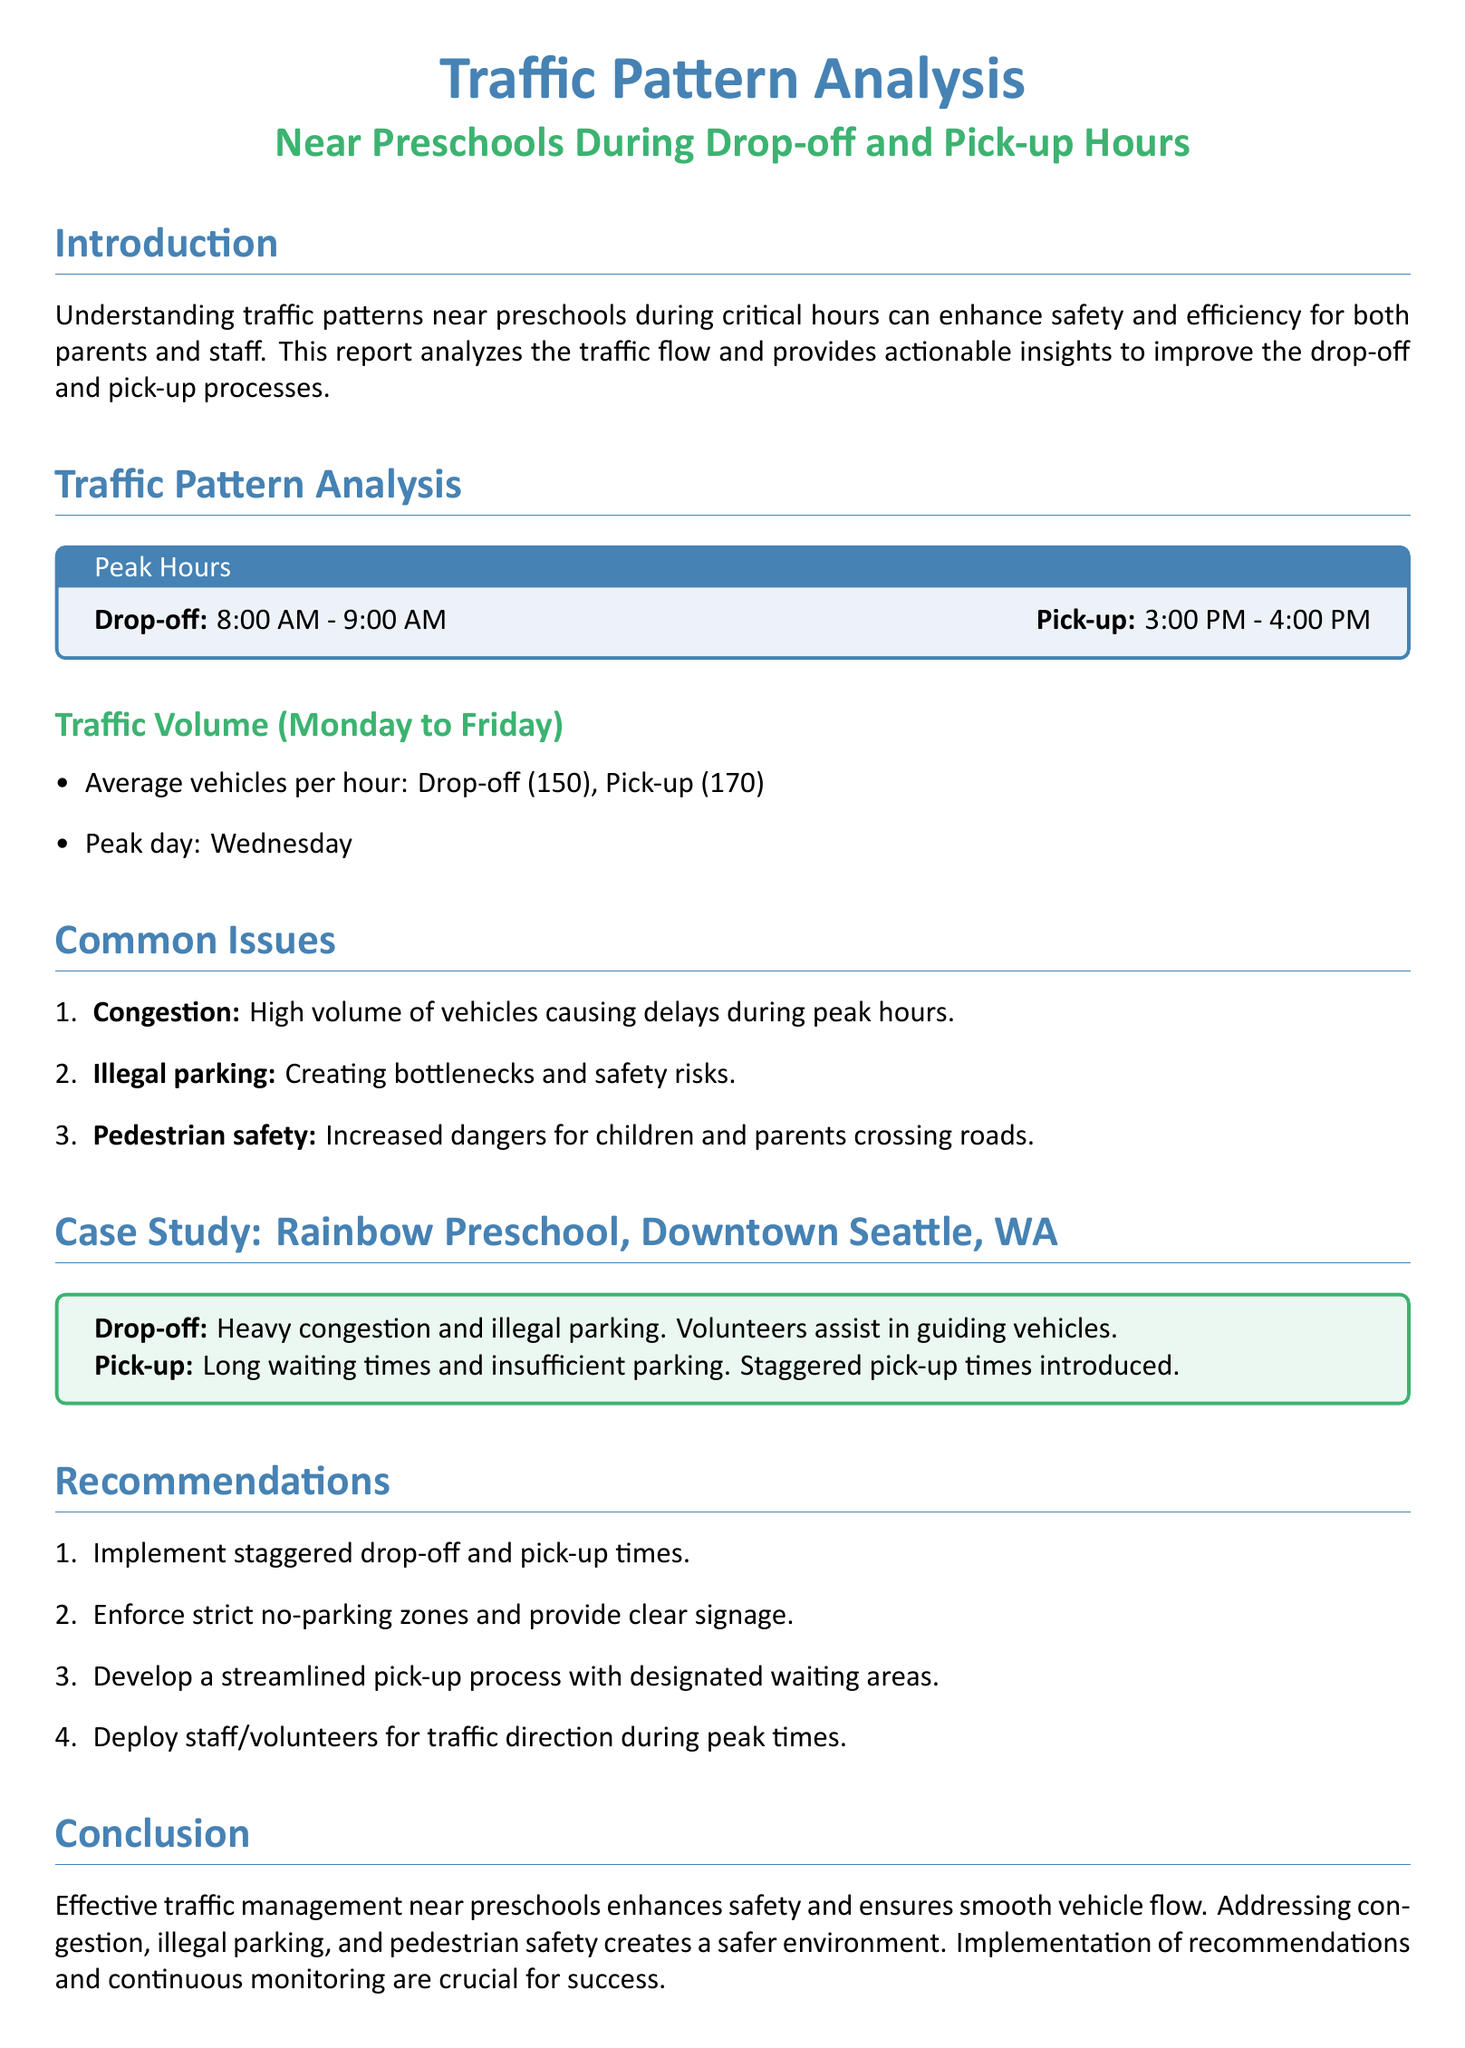What are the peak drop-off hours? The peak drop-off hours are specifically mentioned in the report as from 8:00 AM to 9:00 AM.
Answer: 8:00 AM - 9:00 AM What is the average number of vehicles during pick-up? The document provides an average vehicle count for pick-up, which is stated to be 170 vehicles per hour.
Answer: 170 What is the peak day for traffic volume? The analysis mentions that the peak day for traffic volume is Wednesday, highlighting significant traffic during that week.
Answer: Wednesday What are some common issues noted in the report? The report lists issues such as congestion, illegal parking, and pedestrian safety, which are all common problems during traffic hours.
Answer: Congestion, illegal parking, pedestrian safety What is a recommendation for improving traffic flow? One of the recommendations for improving traffic flow includes implementing staggered drop-off and pick-up times, as noted in the recommendations section.
Answer: Staggered drop-off and pick-up times What organization is highlighted in the case study? The case study focuses on Rainbow Preschool located in Downtown Seattle, WA, which provides specific examples of traffic management issues.
Answer: Rainbow Preschool What is the average number of vehicles during drop-off? The report states that the average number of vehicles during drop-off is mentioned to be 150 vehicles per hour.
Answer: 150 What action does the report suggest regarding parking? The report suggests enforcing strict no-parking zones to enhance safety and alleviate congestion during peak hours.
Answer: Enforce strict no-parking zones 